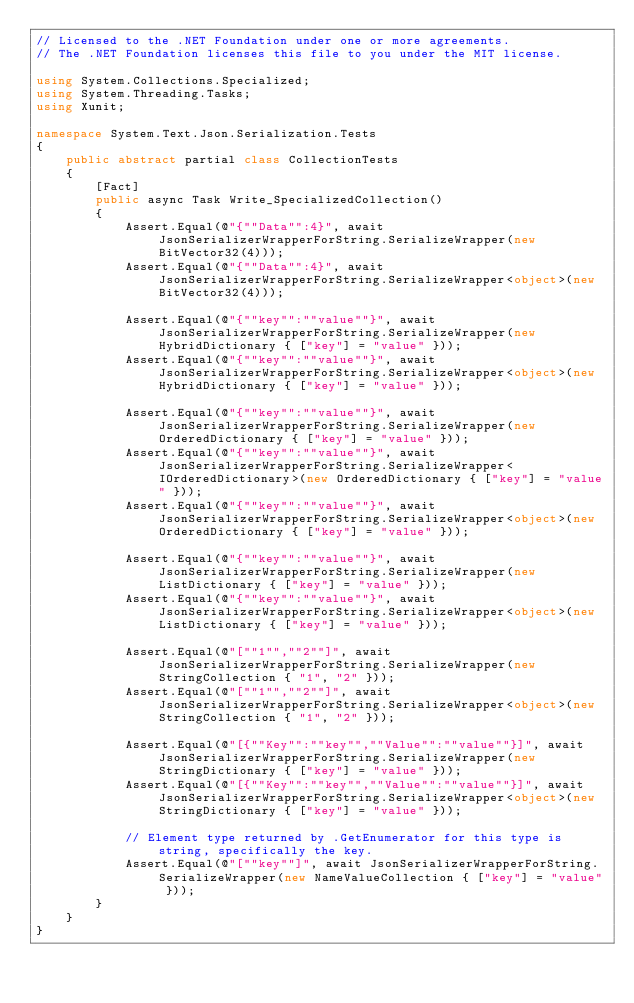Convert code to text. <code><loc_0><loc_0><loc_500><loc_500><_C#_>// Licensed to the .NET Foundation under one or more agreements.
// The .NET Foundation licenses this file to you under the MIT license.

using System.Collections.Specialized;
using System.Threading.Tasks;
using Xunit;

namespace System.Text.Json.Serialization.Tests
{
    public abstract partial class CollectionTests
    {
        [Fact]
        public async Task Write_SpecializedCollection()
        {
            Assert.Equal(@"{""Data"":4}", await JsonSerializerWrapperForString.SerializeWrapper(new BitVector32(4)));
            Assert.Equal(@"{""Data"":4}", await JsonSerializerWrapperForString.SerializeWrapper<object>(new BitVector32(4)));

            Assert.Equal(@"{""key"":""value""}", await JsonSerializerWrapperForString.SerializeWrapper(new HybridDictionary { ["key"] = "value" }));
            Assert.Equal(@"{""key"":""value""}", await JsonSerializerWrapperForString.SerializeWrapper<object>(new HybridDictionary { ["key"] = "value" }));

            Assert.Equal(@"{""key"":""value""}", await JsonSerializerWrapperForString.SerializeWrapper(new OrderedDictionary { ["key"] = "value" }));
            Assert.Equal(@"{""key"":""value""}", await JsonSerializerWrapperForString.SerializeWrapper<IOrderedDictionary>(new OrderedDictionary { ["key"] = "value" }));
            Assert.Equal(@"{""key"":""value""}", await JsonSerializerWrapperForString.SerializeWrapper<object>(new OrderedDictionary { ["key"] = "value" }));

            Assert.Equal(@"{""key"":""value""}", await JsonSerializerWrapperForString.SerializeWrapper(new ListDictionary { ["key"] = "value" }));
            Assert.Equal(@"{""key"":""value""}", await JsonSerializerWrapperForString.SerializeWrapper<object>(new ListDictionary { ["key"] = "value" }));

            Assert.Equal(@"[""1"",""2""]", await JsonSerializerWrapperForString.SerializeWrapper(new StringCollection { "1", "2" }));
            Assert.Equal(@"[""1"",""2""]", await JsonSerializerWrapperForString.SerializeWrapper<object>(new StringCollection { "1", "2" }));

            Assert.Equal(@"[{""Key"":""key"",""Value"":""value""}]", await JsonSerializerWrapperForString.SerializeWrapper(new StringDictionary { ["key"] = "value" }));
            Assert.Equal(@"[{""Key"":""key"",""Value"":""value""}]", await JsonSerializerWrapperForString.SerializeWrapper<object>(new StringDictionary { ["key"] = "value" }));

            // Element type returned by .GetEnumerator for this type is string, specifically the key.
            Assert.Equal(@"[""key""]", await JsonSerializerWrapperForString.SerializeWrapper(new NameValueCollection { ["key"] = "value" }));
        }
    }
}
</code> 